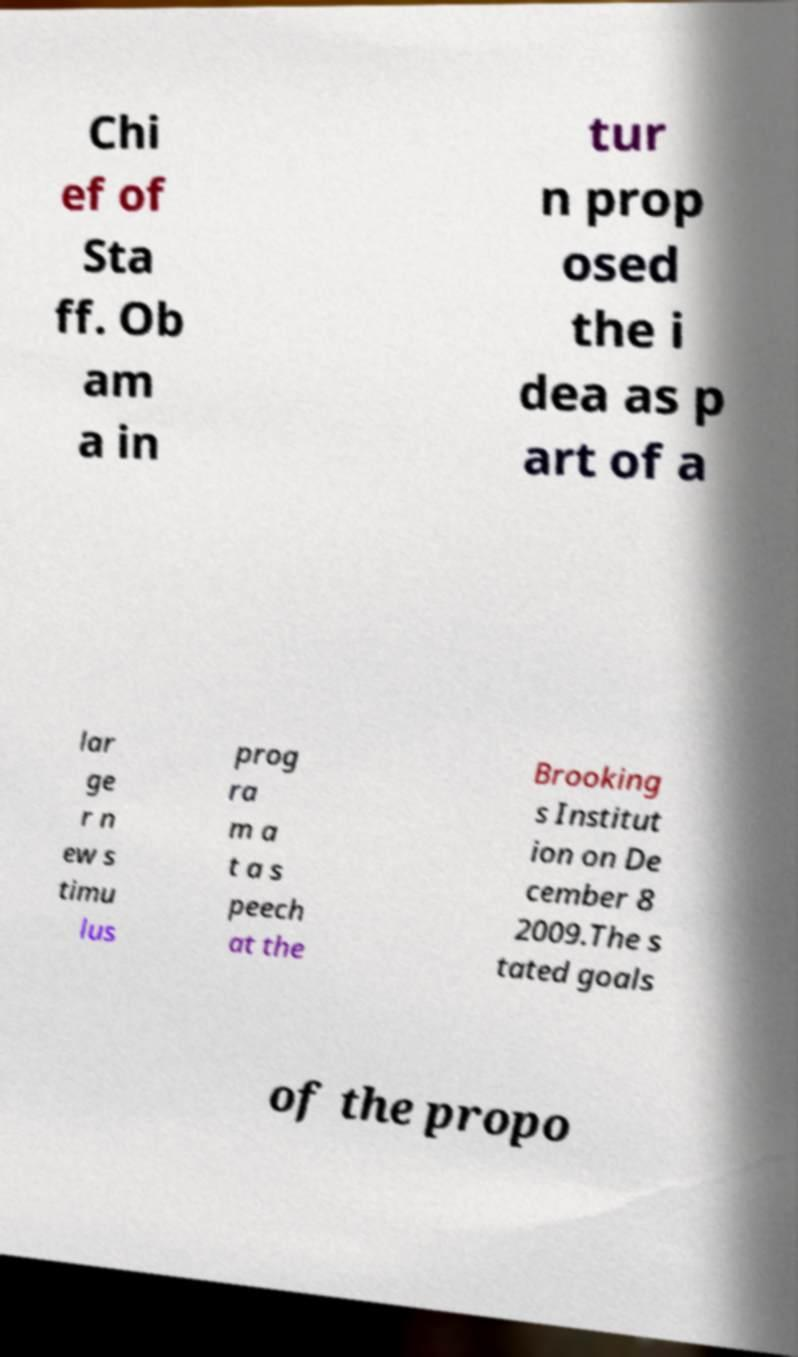What messages or text are displayed in this image? I need them in a readable, typed format. Chi ef of Sta ff. Ob am a in tur n prop osed the i dea as p art of a lar ge r n ew s timu lus prog ra m a t a s peech at the Brooking s Institut ion on De cember 8 2009.The s tated goals of the propo 